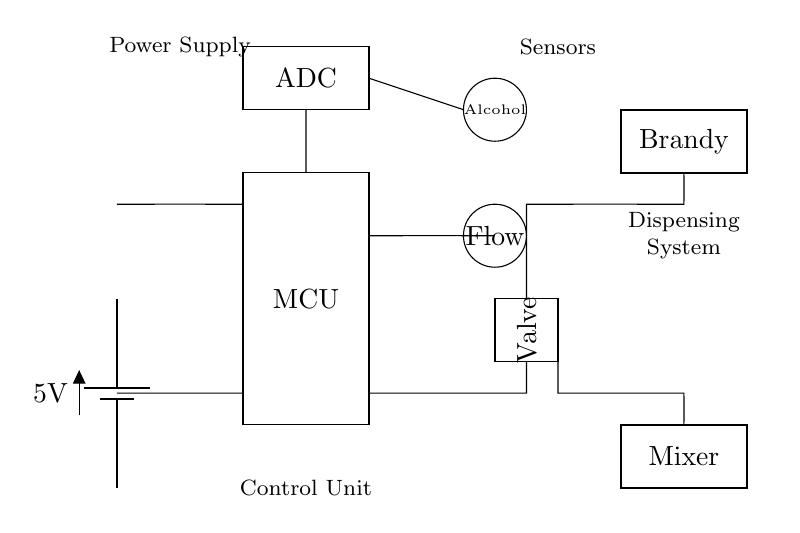What is the voltage of this circuit? The voltage is 5V, which is indicated by the battery symbol at the top left of the circuit diagram.
Answer: 5V What component measures the flow rate? The component that measures the flow rate is the flow sensor, which is represented by a circle labeled "Flow" in the circuit.
Answer: Flow sensor Which component controls the dispensing of brandy? The component that controls the dispensing of brandy is the solenoid valve, shown as a rectangle labeled "Valve" in the circuit diagram.
Answer: Solenoid valve What is the function of the ADC in this circuit? The ADC, or Analog to Digital Converter, converts the analog signals from the alcohol sensor and flow sensor into digital data for processing by the microcontroller.
Answer: Data conversion How does the alcohol sensor communicate with the microcontroller? The alcohol sensor sends its readings to the microcontroller through a direct connection, specifically the short line leading to the MCU from the sensor.
Answer: Direct connection What is the purpose of the mixing chamber in the circuit? The mixing chamber is where the brandy and other ingredients are combined to create the desired cocktail before serving.
Answer: Combine ingredients What type of circuit is represented here? This is an automated dispensing circuit that integrates sensors and a microcontroller for precise cocktail mixing.
Answer: Automated dispensing circuit 